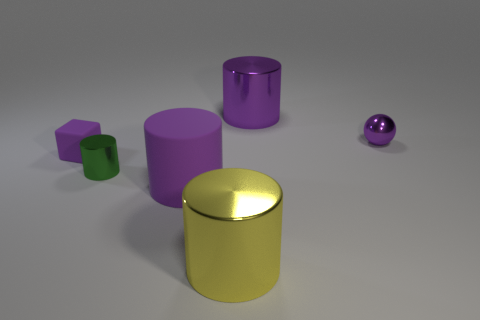Subtract all red balls. How many purple cylinders are left? 2 Subtract all purple metallic cylinders. How many cylinders are left? 3 Subtract all yellow cylinders. How many cylinders are left? 3 Add 2 tiny metallic things. How many objects exist? 8 Subtract all brown cylinders. Subtract all cyan cubes. How many cylinders are left? 4 Subtract all cylinders. How many objects are left? 2 Add 5 tiny metal objects. How many tiny metal objects are left? 7 Add 3 yellow metal cylinders. How many yellow metal cylinders exist? 4 Subtract 0 cyan cylinders. How many objects are left? 6 Subtract all small blue shiny cubes. Subtract all rubber objects. How many objects are left? 4 